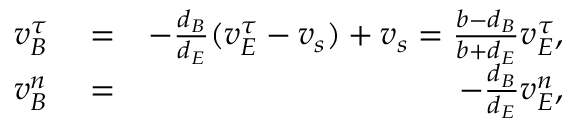<formula> <loc_0><loc_0><loc_500><loc_500>\begin{array} { r l r } { v _ { B } ^ { \tau } } & = } & { - \frac { d _ { B } } { d _ { E } } ( v _ { E } ^ { \tau } - v _ { s } ) + v _ { s } = \frac { b - d _ { B } } { b + d _ { E } } v _ { E } ^ { \tau } , } \\ { v _ { B } ^ { n } } & = } & { - \frac { d _ { B } } { d _ { E } } v _ { E } ^ { n } , } \end{array}</formula> 